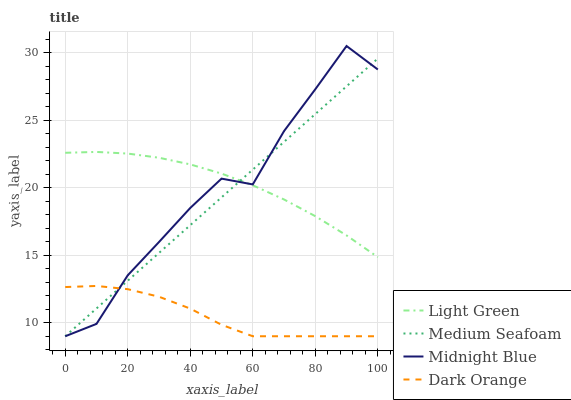Does Dark Orange have the minimum area under the curve?
Answer yes or no. Yes. Does Light Green have the maximum area under the curve?
Answer yes or no. Yes. Does Medium Seafoam have the minimum area under the curve?
Answer yes or no. No. Does Medium Seafoam have the maximum area under the curve?
Answer yes or no. No. Is Medium Seafoam the smoothest?
Answer yes or no. Yes. Is Midnight Blue the roughest?
Answer yes or no. Yes. Is Light Green the smoothest?
Answer yes or no. No. Is Light Green the roughest?
Answer yes or no. No. Does Dark Orange have the lowest value?
Answer yes or no. Yes. Does Light Green have the lowest value?
Answer yes or no. No. Does Midnight Blue have the highest value?
Answer yes or no. Yes. Does Medium Seafoam have the highest value?
Answer yes or no. No. Is Dark Orange less than Light Green?
Answer yes or no. Yes. Is Light Green greater than Dark Orange?
Answer yes or no. Yes. Does Midnight Blue intersect Light Green?
Answer yes or no. Yes. Is Midnight Blue less than Light Green?
Answer yes or no. No. Is Midnight Blue greater than Light Green?
Answer yes or no. No. Does Dark Orange intersect Light Green?
Answer yes or no. No. 